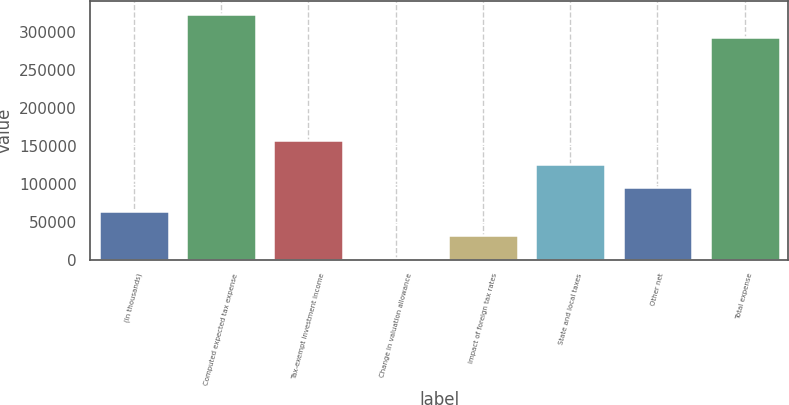<chart> <loc_0><loc_0><loc_500><loc_500><bar_chart><fcel>(In thousands)<fcel>Computed expected tax expense<fcel>Tax-exempt investment income<fcel>Change in valuation allowance<fcel>Impact of foreign tax rates<fcel>State and local taxes<fcel>Other net<fcel>Total expense<nl><fcel>63886.6<fcel>324186<fcel>157586<fcel>1420<fcel>32653.3<fcel>126353<fcel>95119.9<fcel>292953<nl></chart> 